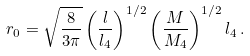<formula> <loc_0><loc_0><loc_500><loc_500>r _ { 0 } = \sqrt { \frac { 8 } { 3 \pi } } \left ( \frac { l } { l _ { 4 } } \right ) ^ { 1 / 2 } \left ( \frac { M } { M _ { 4 } } \right ) ^ { 1 / 2 } l _ { 4 } \, .</formula> 